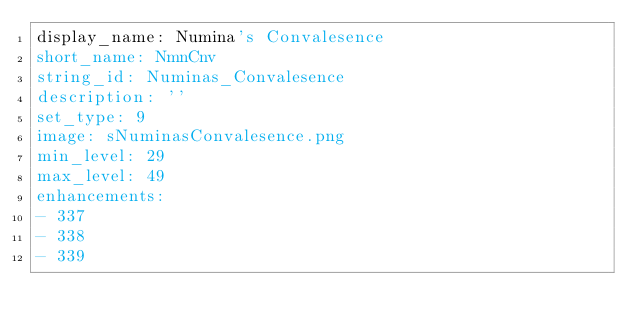Convert code to text. <code><loc_0><loc_0><loc_500><loc_500><_YAML_>display_name: Numina's Convalesence
short_name: NmnCnv
string_id: Numinas_Convalesence
description: ''
set_type: 9
image: sNuminasConvalesence.png
min_level: 29
max_level: 49
enhancements:
- 337
- 338
- 339</code> 